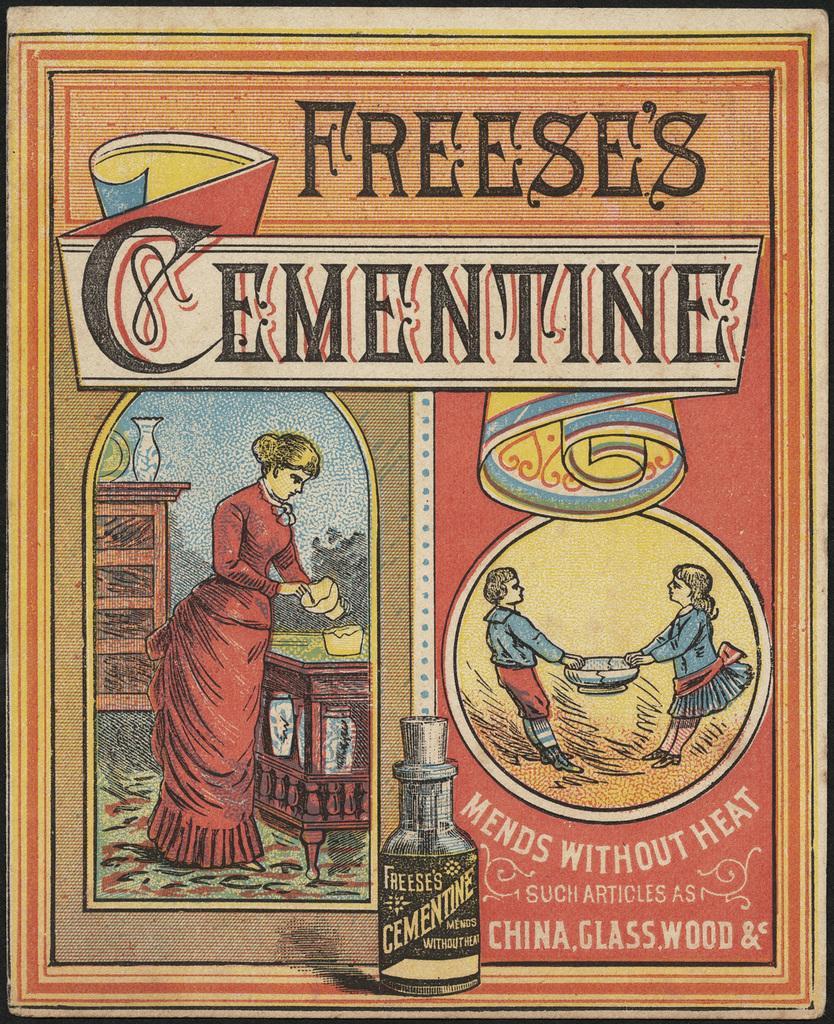Please provide a concise description of this image. In this image there is a poster, on that poster there is some text and a woman and two kids and a bottle. 